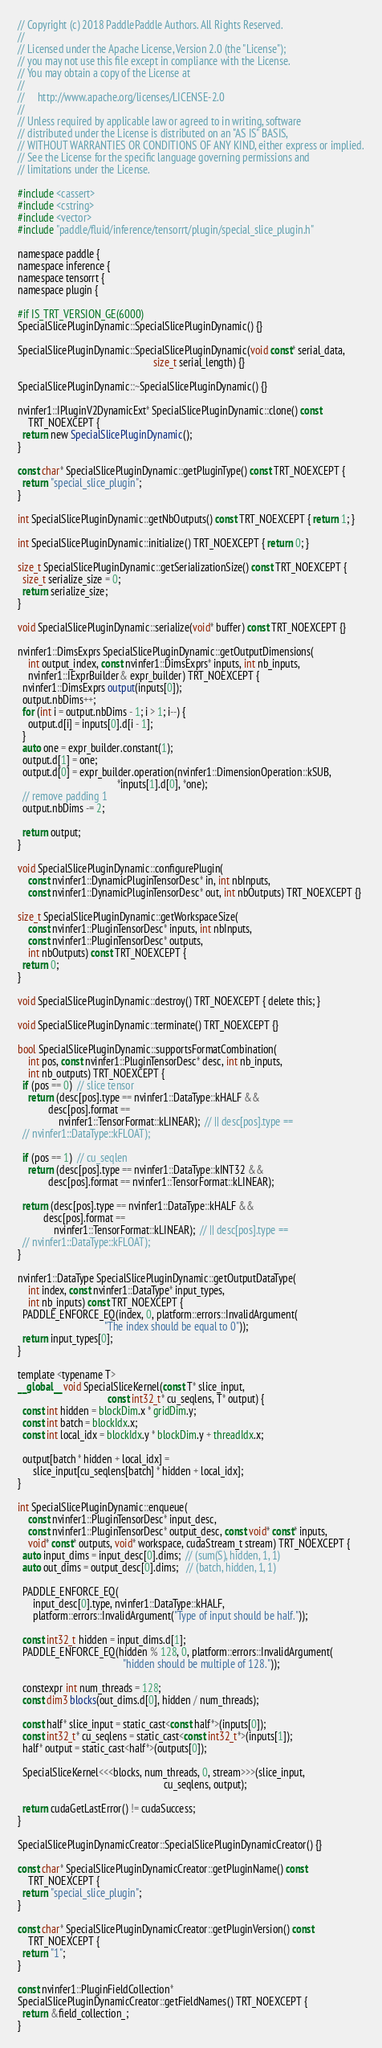<code> <loc_0><loc_0><loc_500><loc_500><_Cuda_>// Copyright (c) 2018 PaddlePaddle Authors. All Rights Reserved.
//
// Licensed under the Apache License, Version 2.0 (the "License");
// you may not use this file except in compliance with the License.
// You may obtain a copy of the License at
//
//     http://www.apache.org/licenses/LICENSE-2.0
//
// Unless required by applicable law or agreed to in writing, software
// distributed under the License is distributed on an "AS IS" BASIS,
// WITHOUT WARRANTIES OR CONDITIONS OF ANY KIND, either express or implied.
// See the License for the specific language governing permissions and
// limitations under the License.

#include <cassert>
#include <cstring>
#include <vector>
#include "paddle/fluid/inference/tensorrt/plugin/special_slice_plugin.h"

namespace paddle {
namespace inference {
namespace tensorrt {
namespace plugin {

#if IS_TRT_VERSION_GE(6000)
SpecialSlicePluginDynamic::SpecialSlicePluginDynamic() {}

SpecialSlicePluginDynamic::SpecialSlicePluginDynamic(void const* serial_data,
                                                     size_t serial_length) {}

SpecialSlicePluginDynamic::~SpecialSlicePluginDynamic() {}

nvinfer1::IPluginV2DynamicExt* SpecialSlicePluginDynamic::clone() const
    TRT_NOEXCEPT {
  return new SpecialSlicePluginDynamic();
}

const char* SpecialSlicePluginDynamic::getPluginType() const TRT_NOEXCEPT {
  return "special_slice_plugin";
}

int SpecialSlicePluginDynamic::getNbOutputs() const TRT_NOEXCEPT { return 1; }

int SpecialSlicePluginDynamic::initialize() TRT_NOEXCEPT { return 0; }

size_t SpecialSlicePluginDynamic::getSerializationSize() const TRT_NOEXCEPT {
  size_t serialize_size = 0;
  return serialize_size;
}

void SpecialSlicePluginDynamic::serialize(void* buffer) const TRT_NOEXCEPT {}

nvinfer1::DimsExprs SpecialSlicePluginDynamic::getOutputDimensions(
    int output_index, const nvinfer1::DimsExprs* inputs, int nb_inputs,
    nvinfer1::IExprBuilder& expr_builder) TRT_NOEXCEPT {
  nvinfer1::DimsExprs output(inputs[0]);
  output.nbDims++;
  for (int i = output.nbDims - 1; i > 1; i--) {
    output.d[i] = inputs[0].d[i - 1];
  }
  auto one = expr_builder.constant(1);
  output.d[1] = one;
  output.d[0] = expr_builder.operation(nvinfer1::DimensionOperation::kSUB,
                                       *inputs[1].d[0], *one);
  // remove padding 1
  output.nbDims -= 2;

  return output;
}

void SpecialSlicePluginDynamic::configurePlugin(
    const nvinfer1::DynamicPluginTensorDesc* in, int nbInputs,
    const nvinfer1::DynamicPluginTensorDesc* out, int nbOutputs) TRT_NOEXCEPT {}

size_t SpecialSlicePluginDynamic::getWorkspaceSize(
    const nvinfer1::PluginTensorDesc* inputs, int nbInputs,
    const nvinfer1::PluginTensorDesc* outputs,
    int nbOutputs) const TRT_NOEXCEPT {
  return 0;
}

void SpecialSlicePluginDynamic::destroy() TRT_NOEXCEPT { delete this; }

void SpecialSlicePluginDynamic::terminate() TRT_NOEXCEPT {}

bool SpecialSlicePluginDynamic::supportsFormatCombination(
    int pos, const nvinfer1::PluginTensorDesc* desc, int nb_inputs,
    int nb_outputs) TRT_NOEXCEPT {
  if (pos == 0)  // slice tensor
    return (desc[pos].type == nvinfer1::DataType::kHALF &&
            desc[pos].format ==
                nvinfer1::TensorFormat::kLINEAR);  // || desc[pos].type ==
  // nvinfer1::DataType::kFLOAT);

  if (pos == 1)  // cu_seqlen
    return (desc[pos].type == nvinfer1::DataType::kINT32 &&
            desc[pos].format == nvinfer1::TensorFormat::kLINEAR);

  return (desc[pos].type == nvinfer1::DataType::kHALF &&
          desc[pos].format ==
              nvinfer1::TensorFormat::kLINEAR);  // || desc[pos].type ==
  // nvinfer1::DataType::kFLOAT);
}

nvinfer1::DataType SpecialSlicePluginDynamic::getOutputDataType(
    int index, const nvinfer1::DataType* input_types,
    int nb_inputs) const TRT_NOEXCEPT {
  PADDLE_ENFORCE_EQ(index, 0, platform::errors::InvalidArgument(
                                  "The index should be equal to 0"));
  return input_types[0];
}

template <typename T>
__global__ void SpecialSliceKernel(const T* slice_input,
                                   const int32_t* cu_seqlens, T* output) {
  const int hidden = blockDim.x * gridDim.y;
  const int batch = blockIdx.x;
  const int local_idx = blockIdx.y * blockDim.y + threadIdx.x;

  output[batch * hidden + local_idx] =
      slice_input[cu_seqlens[batch] * hidden + local_idx];
}

int SpecialSlicePluginDynamic::enqueue(
    const nvinfer1::PluginTensorDesc* input_desc,
    const nvinfer1::PluginTensorDesc* output_desc, const void* const* inputs,
    void* const* outputs, void* workspace, cudaStream_t stream) TRT_NOEXCEPT {
  auto input_dims = input_desc[0].dims;  // (sum(S), hidden, 1, 1)
  auto out_dims = output_desc[0].dims;   // (batch, hidden, 1, 1)

  PADDLE_ENFORCE_EQ(
      input_desc[0].type, nvinfer1::DataType::kHALF,
      platform::errors::InvalidArgument("Type of input should be half."));

  const int32_t hidden = input_dims.d[1];
  PADDLE_ENFORCE_EQ(hidden % 128, 0, platform::errors::InvalidArgument(
                                         "hidden should be multiple of 128."));

  constexpr int num_threads = 128;
  const dim3 blocks(out_dims.d[0], hidden / num_threads);

  const half* slice_input = static_cast<const half*>(inputs[0]);
  const int32_t* cu_seqlens = static_cast<const int32_t*>(inputs[1]);
  half* output = static_cast<half*>(outputs[0]);

  SpecialSliceKernel<<<blocks, num_threads, 0, stream>>>(slice_input,
                                                         cu_seqlens, output);

  return cudaGetLastError() != cudaSuccess;
}

SpecialSlicePluginDynamicCreator::SpecialSlicePluginDynamicCreator() {}

const char* SpecialSlicePluginDynamicCreator::getPluginName() const
    TRT_NOEXCEPT {
  return "special_slice_plugin";
}

const char* SpecialSlicePluginDynamicCreator::getPluginVersion() const
    TRT_NOEXCEPT {
  return "1";
}

const nvinfer1::PluginFieldCollection*
SpecialSlicePluginDynamicCreator::getFieldNames() TRT_NOEXCEPT {
  return &field_collection_;
}
</code> 